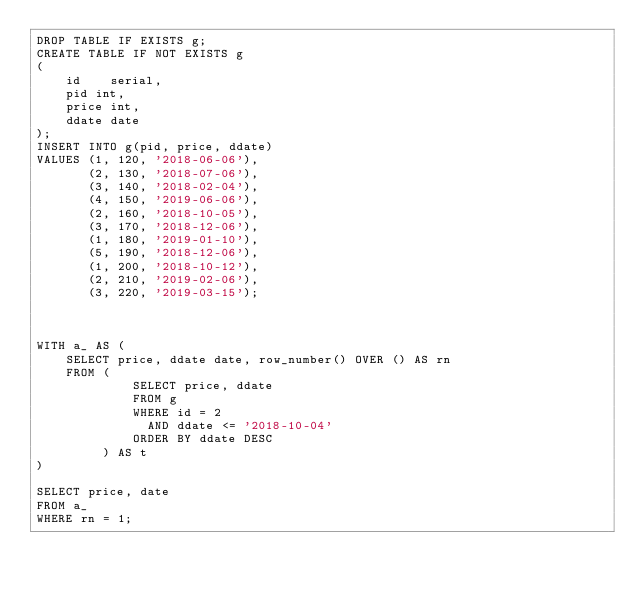Convert code to text. <code><loc_0><loc_0><loc_500><loc_500><_SQL_>DROP TABLE IF EXISTS g;
CREATE TABLE IF NOT EXISTS g
(
    id    serial,
    pid int,
    price int,
    ddate date
);
INSERT INTO g(pid, price, ddate)
VALUES (1, 120, '2018-06-06'),
       (2, 130, '2018-07-06'),
       (3, 140, '2018-02-04'),
       (4, 150, '2019-06-06'),
       (2, 160, '2018-10-05'),
       (3, 170, '2018-12-06'),
       (1, 180, '2019-01-10'),
       (5, 190, '2018-12-06'),
       (1, 200, '2018-10-12'),
       (2, 210, '2019-02-06'),
       (3, 220, '2019-03-15');



WITH a_ AS (
    SELECT price, ddate date, row_number() OVER () AS rn
    FROM (
             SELECT price, ddate
             FROM g
             WHERE id = 2
               AND ddate <= '2018-10-04'
             ORDER BY ddate DESC
         ) AS t
)

SELECT price, date
FROM a_
WHERE rn = 1;</code> 